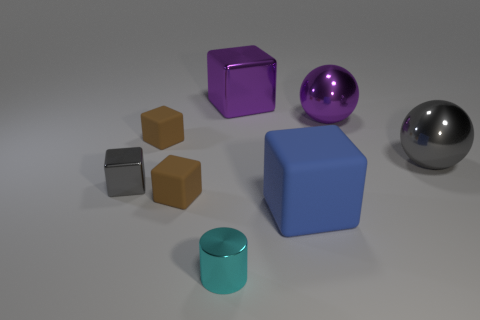How many objects are purple objects that are on the right side of the purple block or tiny gray metallic cubes?
Ensure brevity in your answer.  2. How many big matte cubes are behind the gray object that is to the right of the cyan cylinder?
Provide a succinct answer. 0. Is the number of small shiny cubes that are behind the gray metallic cube less than the number of large metallic objects on the right side of the blue matte thing?
Provide a succinct answer. Yes. There is a tiny brown object behind the tiny metallic object behind the big matte cube; what is its shape?
Keep it short and to the point. Cube. What number of other objects are there of the same material as the big purple sphere?
Your answer should be very brief. 4. Is the number of gray shiny balls greater than the number of tiny brown matte objects?
Keep it short and to the point. No. There is a shiny block that is in front of the brown matte cube behind the gray object behind the tiny gray metal thing; what is its size?
Give a very brief answer. Small. Is the size of the gray metal block the same as the cyan cylinder in front of the gray shiny ball?
Keep it short and to the point. Yes. Are there fewer brown rubber blocks that are behind the gray ball than purple matte cubes?
Your answer should be very brief. No. What number of big objects have the same color as the big shiny cube?
Your answer should be compact. 1. 